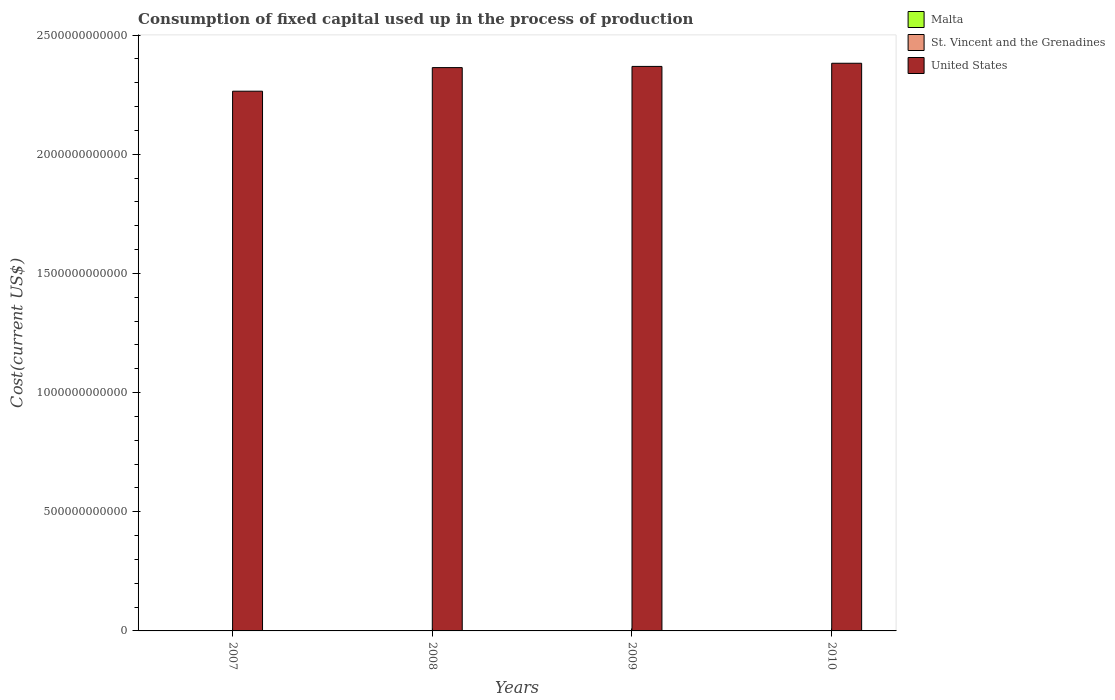How many different coloured bars are there?
Make the answer very short. 3. How many bars are there on the 1st tick from the left?
Ensure brevity in your answer.  3. What is the amount consumed in the process of production in Malta in 2007?
Your answer should be very brief. 1.02e+09. Across all years, what is the maximum amount consumed in the process of production in United States?
Make the answer very short. 2.38e+12. Across all years, what is the minimum amount consumed in the process of production in St. Vincent and the Grenadines?
Offer a terse response. 3.22e+07. In which year was the amount consumed in the process of production in Malta maximum?
Give a very brief answer. 2008. In which year was the amount consumed in the process of production in Malta minimum?
Ensure brevity in your answer.  2007. What is the total amount consumed in the process of production in Malta in the graph?
Your response must be concise. 4.44e+09. What is the difference between the amount consumed in the process of production in Malta in 2007 and that in 2008?
Make the answer very short. -1.27e+08. What is the difference between the amount consumed in the process of production in United States in 2008 and the amount consumed in the process of production in Malta in 2010?
Your answer should be compact. 2.36e+12. What is the average amount consumed in the process of production in St. Vincent and the Grenadines per year?
Make the answer very short. 3.32e+07. In the year 2008, what is the difference between the amount consumed in the process of production in Malta and amount consumed in the process of production in St. Vincent and the Grenadines?
Offer a terse response. 1.12e+09. In how many years, is the amount consumed in the process of production in United States greater than 500000000000 US$?
Your answer should be very brief. 4. What is the ratio of the amount consumed in the process of production in United States in 2008 to that in 2009?
Provide a short and direct response. 1. What is the difference between the highest and the second highest amount consumed in the process of production in St. Vincent and the Grenadines?
Make the answer very short. 1.61e+06. What is the difference between the highest and the lowest amount consumed in the process of production in St. Vincent and the Grenadines?
Your answer should be compact. 2.38e+06. In how many years, is the amount consumed in the process of production in United States greater than the average amount consumed in the process of production in United States taken over all years?
Provide a succinct answer. 3. What does the 3rd bar from the left in 2007 represents?
Give a very brief answer. United States. What does the 2nd bar from the right in 2009 represents?
Offer a very short reply. St. Vincent and the Grenadines. Is it the case that in every year, the sum of the amount consumed in the process of production in St. Vincent and the Grenadines and amount consumed in the process of production in Malta is greater than the amount consumed in the process of production in United States?
Provide a short and direct response. No. How many bars are there?
Your answer should be very brief. 12. Are all the bars in the graph horizontal?
Your answer should be compact. No. What is the difference between two consecutive major ticks on the Y-axis?
Your response must be concise. 5.00e+11. Are the values on the major ticks of Y-axis written in scientific E-notation?
Your response must be concise. No. Does the graph contain any zero values?
Keep it short and to the point. No. How many legend labels are there?
Offer a terse response. 3. What is the title of the graph?
Provide a short and direct response. Consumption of fixed capital used up in the process of production. Does "United Arab Emirates" appear as one of the legend labels in the graph?
Provide a short and direct response. No. What is the label or title of the Y-axis?
Keep it short and to the point. Cost(current US$). What is the Cost(current US$) in Malta in 2007?
Offer a terse response. 1.02e+09. What is the Cost(current US$) of St. Vincent and the Grenadines in 2007?
Provide a succinct answer. 3.30e+07. What is the Cost(current US$) of United States in 2007?
Provide a short and direct response. 2.26e+12. What is the Cost(current US$) in Malta in 2008?
Offer a very short reply. 1.15e+09. What is the Cost(current US$) of St. Vincent and the Grenadines in 2008?
Keep it short and to the point. 3.46e+07. What is the Cost(current US$) of United States in 2008?
Your response must be concise. 2.36e+12. What is the Cost(current US$) of Malta in 2009?
Give a very brief answer. 1.14e+09. What is the Cost(current US$) of St. Vincent and the Grenadines in 2009?
Your answer should be very brief. 3.29e+07. What is the Cost(current US$) of United States in 2009?
Make the answer very short. 2.37e+12. What is the Cost(current US$) in Malta in 2010?
Offer a very short reply. 1.13e+09. What is the Cost(current US$) in St. Vincent and the Grenadines in 2010?
Keep it short and to the point. 3.22e+07. What is the Cost(current US$) in United States in 2010?
Keep it short and to the point. 2.38e+12. Across all years, what is the maximum Cost(current US$) in Malta?
Offer a terse response. 1.15e+09. Across all years, what is the maximum Cost(current US$) in St. Vincent and the Grenadines?
Keep it short and to the point. 3.46e+07. Across all years, what is the maximum Cost(current US$) of United States?
Keep it short and to the point. 2.38e+12. Across all years, what is the minimum Cost(current US$) of Malta?
Offer a very short reply. 1.02e+09. Across all years, what is the minimum Cost(current US$) in St. Vincent and the Grenadines?
Your answer should be very brief. 3.22e+07. Across all years, what is the minimum Cost(current US$) in United States?
Offer a terse response. 2.26e+12. What is the total Cost(current US$) in Malta in the graph?
Your answer should be very brief. 4.44e+09. What is the total Cost(current US$) in St. Vincent and the Grenadines in the graph?
Make the answer very short. 1.33e+08. What is the total Cost(current US$) in United States in the graph?
Offer a terse response. 9.38e+12. What is the difference between the Cost(current US$) of Malta in 2007 and that in 2008?
Make the answer very short. -1.27e+08. What is the difference between the Cost(current US$) in St. Vincent and the Grenadines in 2007 and that in 2008?
Your answer should be very brief. -1.61e+06. What is the difference between the Cost(current US$) in United States in 2007 and that in 2008?
Your answer should be very brief. -9.90e+1. What is the difference between the Cost(current US$) of Malta in 2007 and that in 2009?
Make the answer very short. -1.16e+08. What is the difference between the Cost(current US$) of St. Vincent and the Grenadines in 2007 and that in 2009?
Ensure brevity in your answer.  1.31e+05. What is the difference between the Cost(current US$) in United States in 2007 and that in 2009?
Make the answer very short. -1.04e+11. What is the difference between the Cost(current US$) of Malta in 2007 and that in 2010?
Give a very brief answer. -1.04e+08. What is the difference between the Cost(current US$) in St. Vincent and the Grenadines in 2007 and that in 2010?
Offer a terse response. 7.76e+05. What is the difference between the Cost(current US$) in United States in 2007 and that in 2010?
Give a very brief answer. -1.17e+11. What is the difference between the Cost(current US$) of Malta in 2008 and that in 2009?
Your answer should be compact. 1.11e+07. What is the difference between the Cost(current US$) in St. Vincent and the Grenadines in 2008 and that in 2009?
Offer a terse response. 1.74e+06. What is the difference between the Cost(current US$) in United States in 2008 and that in 2009?
Keep it short and to the point. -4.99e+09. What is the difference between the Cost(current US$) of Malta in 2008 and that in 2010?
Offer a very short reply. 2.29e+07. What is the difference between the Cost(current US$) of St. Vincent and the Grenadines in 2008 and that in 2010?
Your answer should be very brief. 2.38e+06. What is the difference between the Cost(current US$) in United States in 2008 and that in 2010?
Your answer should be very brief. -1.82e+1. What is the difference between the Cost(current US$) in Malta in 2009 and that in 2010?
Your response must be concise. 1.18e+07. What is the difference between the Cost(current US$) in St. Vincent and the Grenadines in 2009 and that in 2010?
Ensure brevity in your answer.  6.45e+05. What is the difference between the Cost(current US$) of United States in 2009 and that in 2010?
Give a very brief answer. -1.32e+1. What is the difference between the Cost(current US$) of Malta in 2007 and the Cost(current US$) of St. Vincent and the Grenadines in 2008?
Keep it short and to the point. 9.88e+08. What is the difference between the Cost(current US$) in Malta in 2007 and the Cost(current US$) in United States in 2008?
Provide a short and direct response. -2.36e+12. What is the difference between the Cost(current US$) of St. Vincent and the Grenadines in 2007 and the Cost(current US$) of United States in 2008?
Provide a short and direct response. -2.36e+12. What is the difference between the Cost(current US$) in Malta in 2007 and the Cost(current US$) in St. Vincent and the Grenadines in 2009?
Your answer should be very brief. 9.90e+08. What is the difference between the Cost(current US$) in Malta in 2007 and the Cost(current US$) in United States in 2009?
Your answer should be compact. -2.37e+12. What is the difference between the Cost(current US$) of St. Vincent and the Grenadines in 2007 and the Cost(current US$) of United States in 2009?
Ensure brevity in your answer.  -2.37e+12. What is the difference between the Cost(current US$) in Malta in 2007 and the Cost(current US$) in St. Vincent and the Grenadines in 2010?
Offer a terse response. 9.91e+08. What is the difference between the Cost(current US$) of Malta in 2007 and the Cost(current US$) of United States in 2010?
Offer a terse response. -2.38e+12. What is the difference between the Cost(current US$) of St. Vincent and the Grenadines in 2007 and the Cost(current US$) of United States in 2010?
Keep it short and to the point. -2.38e+12. What is the difference between the Cost(current US$) of Malta in 2008 and the Cost(current US$) of St. Vincent and the Grenadines in 2009?
Make the answer very short. 1.12e+09. What is the difference between the Cost(current US$) in Malta in 2008 and the Cost(current US$) in United States in 2009?
Give a very brief answer. -2.37e+12. What is the difference between the Cost(current US$) in St. Vincent and the Grenadines in 2008 and the Cost(current US$) in United States in 2009?
Offer a very short reply. -2.37e+12. What is the difference between the Cost(current US$) of Malta in 2008 and the Cost(current US$) of St. Vincent and the Grenadines in 2010?
Your answer should be compact. 1.12e+09. What is the difference between the Cost(current US$) of Malta in 2008 and the Cost(current US$) of United States in 2010?
Your response must be concise. -2.38e+12. What is the difference between the Cost(current US$) in St. Vincent and the Grenadines in 2008 and the Cost(current US$) in United States in 2010?
Provide a short and direct response. -2.38e+12. What is the difference between the Cost(current US$) in Malta in 2009 and the Cost(current US$) in St. Vincent and the Grenadines in 2010?
Provide a short and direct response. 1.11e+09. What is the difference between the Cost(current US$) of Malta in 2009 and the Cost(current US$) of United States in 2010?
Provide a short and direct response. -2.38e+12. What is the difference between the Cost(current US$) of St. Vincent and the Grenadines in 2009 and the Cost(current US$) of United States in 2010?
Your answer should be very brief. -2.38e+12. What is the average Cost(current US$) of Malta per year?
Your answer should be compact. 1.11e+09. What is the average Cost(current US$) in St. Vincent and the Grenadines per year?
Your answer should be very brief. 3.32e+07. What is the average Cost(current US$) in United States per year?
Your answer should be very brief. 2.34e+12. In the year 2007, what is the difference between the Cost(current US$) in Malta and Cost(current US$) in St. Vincent and the Grenadines?
Your response must be concise. 9.90e+08. In the year 2007, what is the difference between the Cost(current US$) of Malta and Cost(current US$) of United States?
Offer a terse response. -2.26e+12. In the year 2007, what is the difference between the Cost(current US$) in St. Vincent and the Grenadines and Cost(current US$) in United States?
Your response must be concise. -2.26e+12. In the year 2008, what is the difference between the Cost(current US$) in Malta and Cost(current US$) in St. Vincent and the Grenadines?
Your answer should be compact. 1.12e+09. In the year 2008, what is the difference between the Cost(current US$) of Malta and Cost(current US$) of United States?
Ensure brevity in your answer.  -2.36e+12. In the year 2008, what is the difference between the Cost(current US$) of St. Vincent and the Grenadines and Cost(current US$) of United States?
Give a very brief answer. -2.36e+12. In the year 2009, what is the difference between the Cost(current US$) of Malta and Cost(current US$) of St. Vincent and the Grenadines?
Offer a terse response. 1.11e+09. In the year 2009, what is the difference between the Cost(current US$) of Malta and Cost(current US$) of United States?
Ensure brevity in your answer.  -2.37e+12. In the year 2009, what is the difference between the Cost(current US$) in St. Vincent and the Grenadines and Cost(current US$) in United States?
Your answer should be very brief. -2.37e+12. In the year 2010, what is the difference between the Cost(current US$) in Malta and Cost(current US$) in St. Vincent and the Grenadines?
Offer a very short reply. 1.09e+09. In the year 2010, what is the difference between the Cost(current US$) in Malta and Cost(current US$) in United States?
Ensure brevity in your answer.  -2.38e+12. In the year 2010, what is the difference between the Cost(current US$) in St. Vincent and the Grenadines and Cost(current US$) in United States?
Your answer should be compact. -2.38e+12. What is the ratio of the Cost(current US$) in Malta in 2007 to that in 2008?
Your answer should be very brief. 0.89. What is the ratio of the Cost(current US$) of St. Vincent and the Grenadines in 2007 to that in 2008?
Offer a terse response. 0.95. What is the ratio of the Cost(current US$) in United States in 2007 to that in 2008?
Provide a short and direct response. 0.96. What is the ratio of the Cost(current US$) of Malta in 2007 to that in 2009?
Provide a short and direct response. 0.9. What is the ratio of the Cost(current US$) in St. Vincent and the Grenadines in 2007 to that in 2009?
Give a very brief answer. 1. What is the ratio of the Cost(current US$) of United States in 2007 to that in 2009?
Give a very brief answer. 0.96. What is the ratio of the Cost(current US$) of Malta in 2007 to that in 2010?
Give a very brief answer. 0.91. What is the ratio of the Cost(current US$) in St. Vincent and the Grenadines in 2007 to that in 2010?
Ensure brevity in your answer.  1.02. What is the ratio of the Cost(current US$) in United States in 2007 to that in 2010?
Ensure brevity in your answer.  0.95. What is the ratio of the Cost(current US$) of Malta in 2008 to that in 2009?
Your answer should be very brief. 1.01. What is the ratio of the Cost(current US$) in St. Vincent and the Grenadines in 2008 to that in 2009?
Keep it short and to the point. 1.05. What is the ratio of the Cost(current US$) of Malta in 2008 to that in 2010?
Offer a very short reply. 1.02. What is the ratio of the Cost(current US$) in St. Vincent and the Grenadines in 2008 to that in 2010?
Provide a short and direct response. 1.07. What is the ratio of the Cost(current US$) of Malta in 2009 to that in 2010?
Your response must be concise. 1.01. What is the difference between the highest and the second highest Cost(current US$) of Malta?
Provide a succinct answer. 1.11e+07. What is the difference between the highest and the second highest Cost(current US$) in St. Vincent and the Grenadines?
Keep it short and to the point. 1.61e+06. What is the difference between the highest and the second highest Cost(current US$) in United States?
Offer a terse response. 1.32e+1. What is the difference between the highest and the lowest Cost(current US$) in Malta?
Your answer should be very brief. 1.27e+08. What is the difference between the highest and the lowest Cost(current US$) in St. Vincent and the Grenadines?
Provide a short and direct response. 2.38e+06. What is the difference between the highest and the lowest Cost(current US$) of United States?
Offer a terse response. 1.17e+11. 